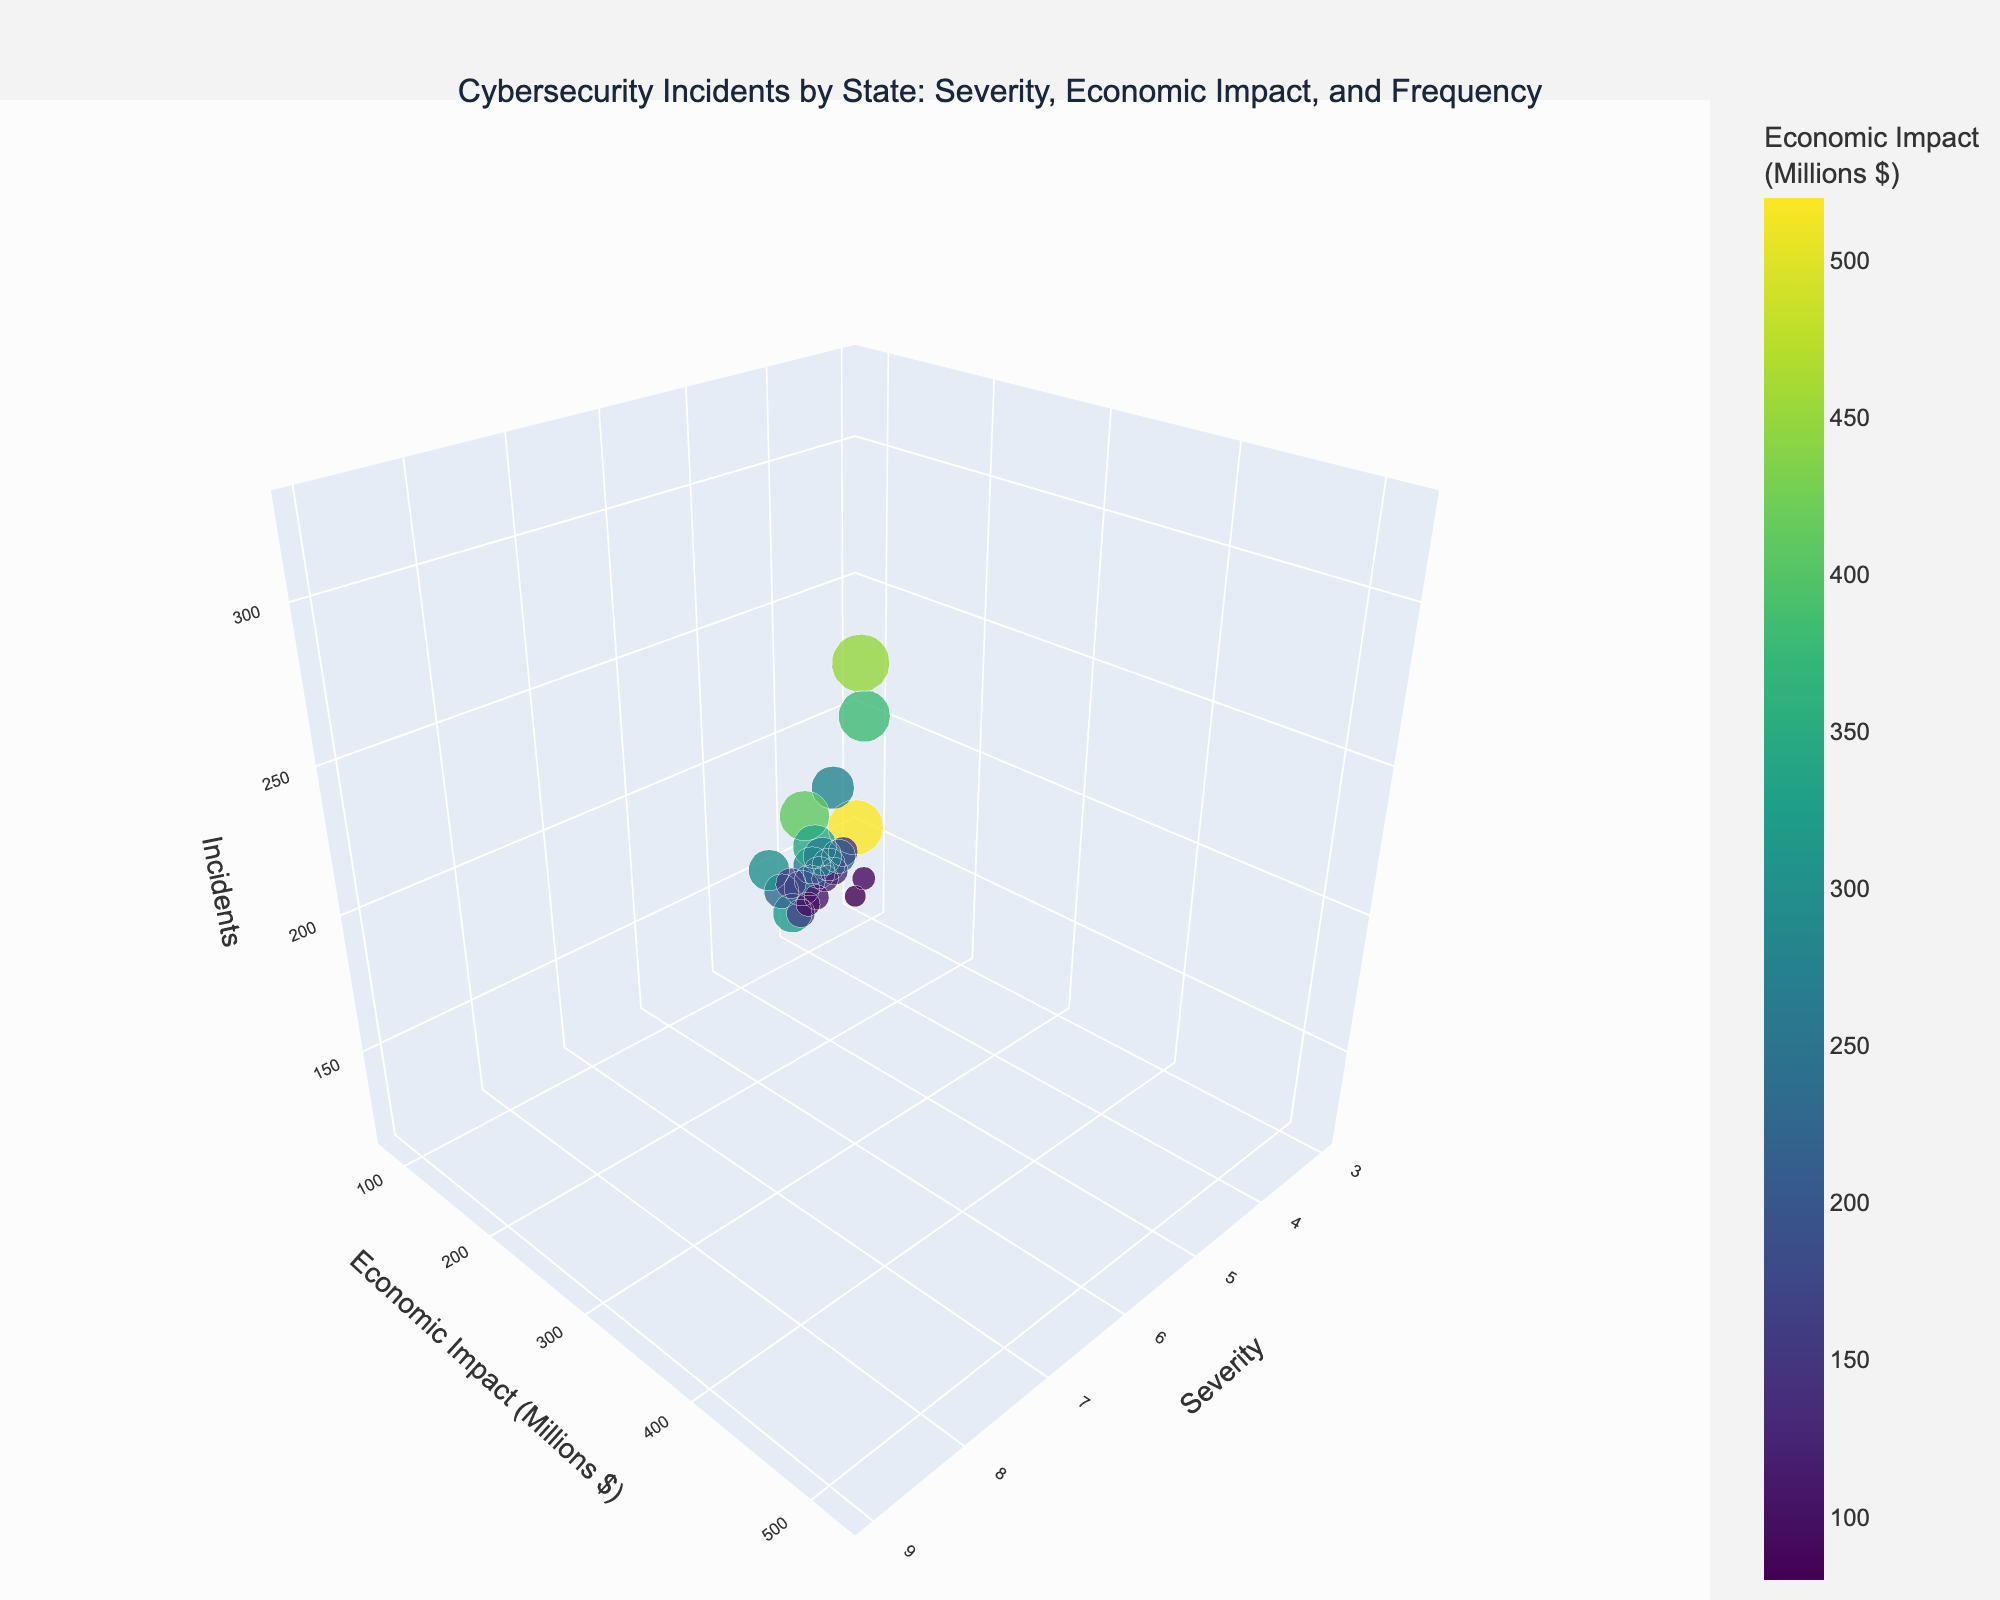What is the title of the figure? The figure's title is located at the top center of the plot. Reading it provides information about the context of the plot.
Answer: Cybersecurity Incidents by State: Severity, Economic Impact, and Frequency What are the axes labels of the figure? The axes are labeled on each axis line within the plot. The x-axis is labeled 'Severity', the y-axis is labeled 'Economic Impact (Millions $)', and the z-axis is labeled 'Incidents'.
Answer: Severity, Economic Impact (Millions $), Incidents Which state has the highest economic impact from cyber incidents? By examining the scatter plot, the economic impact can be judged by the color intensity. The state with the highest economic impact will have the highest value on the y-axis. Using the hover template or the color legend helps identify the specific state.
Answer: New York Which states have the lowest severity of cyber incidents? The lowest severity can be determined by examining the values on the x-axis. States with the smallest x-axis values (Severity) have the lowest severity.
Answer: Tennessee, Missouri Which state's data point is represented by the largest marker size? Marker size represents the number of incidents. The state with the largest marker indicates it has the highest number of incidents. Looking at the plot and finding the largest marker identifies the state.
Answer: California How does the economic impact of cybersecurity incidents in Virginia compare to that in Washington? By examining the position of Virginia and Washington on the y-axis, one can determine the economic impacts for both states. Virginia's and Washington's economic impacts can be directly compared by their vertical positions on the plot.
Answer: Virginia has a higher economic impact than Washington Which states are represented in the plot by markers colored in the most vibrant shades, and what does that indicate? The most vibrant colors on the color scale will have the highest values. States represented by the most vibrant shades indicate a higher economic impact. Identifying these states involves checking the color legend and finding these markers.
Answer: New York, California What can you infer about the relationship between severity and the number of incidents? Observing the scatter plot and noting the distribution of severity against the number of incidents (z-axis) can help infer any trend or relationship. A visual analysis will reveal if there's a correlation between higher severity and the number of incidents.
Answer: Higher severity tends to have a higher number of incidents Identify a state with moderate severity but relatively low economic impact. A state's point with moderate severity (mid-range x-axis) and relatively low on the y-axis will fit this description. Checking the scatter plot for these parameters helps find the specific state.
Answer: Ohio How do incidents in California compare to those in Florida in terms of frequency and severity? Comparing the positions of both states on the x and z-axes. California and Florida’s markers will provide information on their severity and number of incidents.
Answer: California has higher severity and more incidents than Florida 